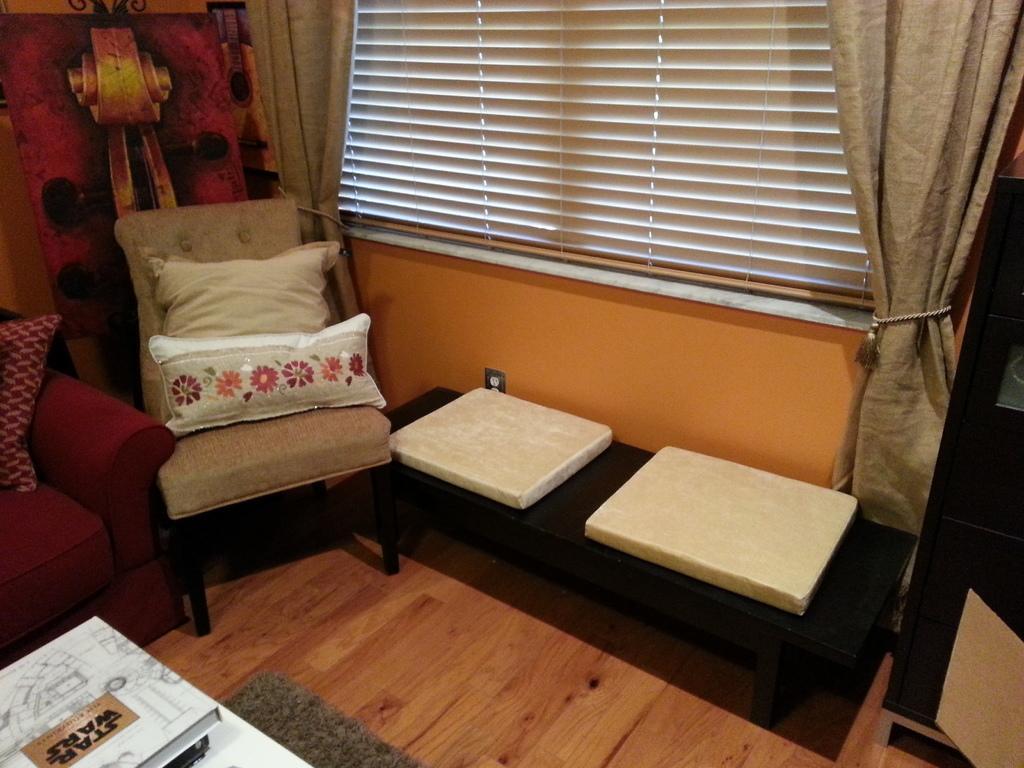How would you summarize this image in a sentence or two? It is a room where at the right corner there is a table behind that there is a wall and shutters with curtains and at the right corner there is a sofa with pillows and a chair with pillows on it, behind that there is a painting and in front of the chair there is a carpet and one table and the books on it. 